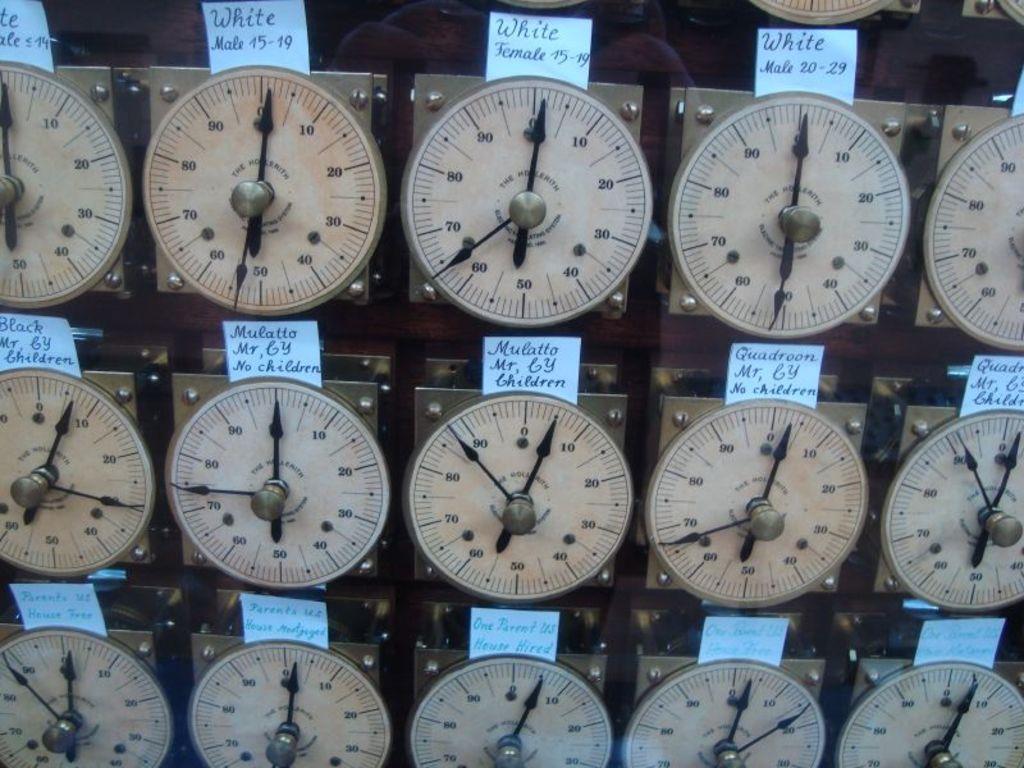Does the person in the second row, 3rd clock have children?
Provide a short and direct response. Yes. What color does the top three clocks have written down?
Offer a very short reply. White. 